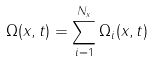Convert formula to latex. <formula><loc_0><loc_0><loc_500><loc_500>\Omega ( x , t ) = \sum _ { i = 1 } ^ { N _ { x } } \Omega _ { i } ( x , t )</formula> 